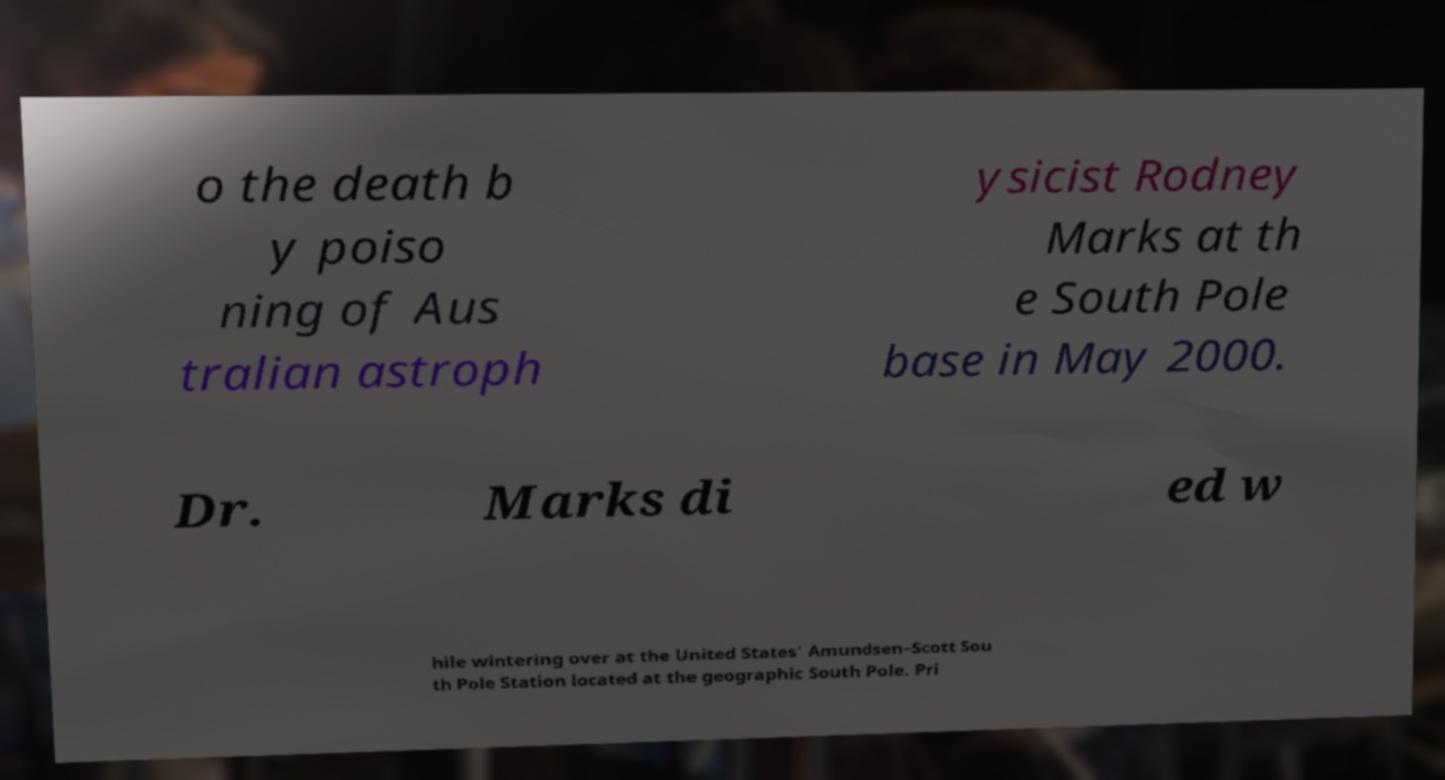Can you accurately transcribe the text from the provided image for me? o the death b y poiso ning of Aus tralian astroph ysicist Rodney Marks at th e South Pole base in May 2000. Dr. Marks di ed w hile wintering over at the United States' Amundsen–Scott Sou th Pole Station located at the geographic South Pole. Pri 